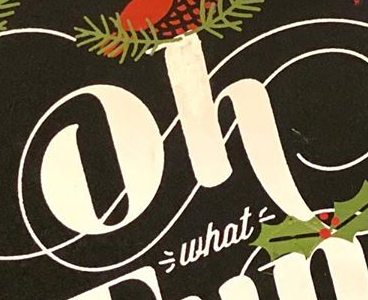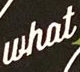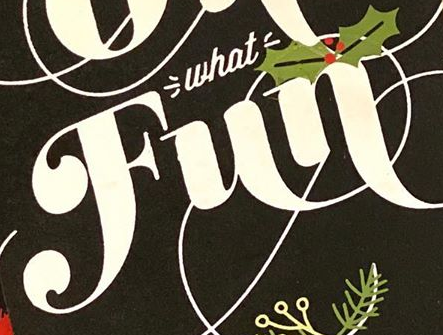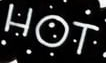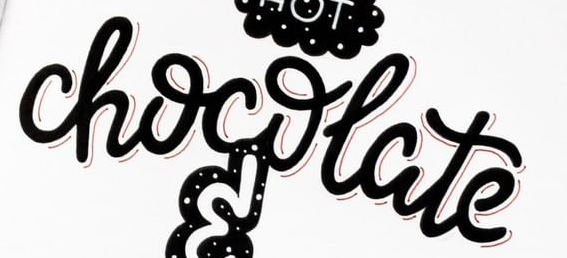Transcribe the words shown in these images in order, separated by a semicolon. oh; what; Fun; HOT; chocolate 